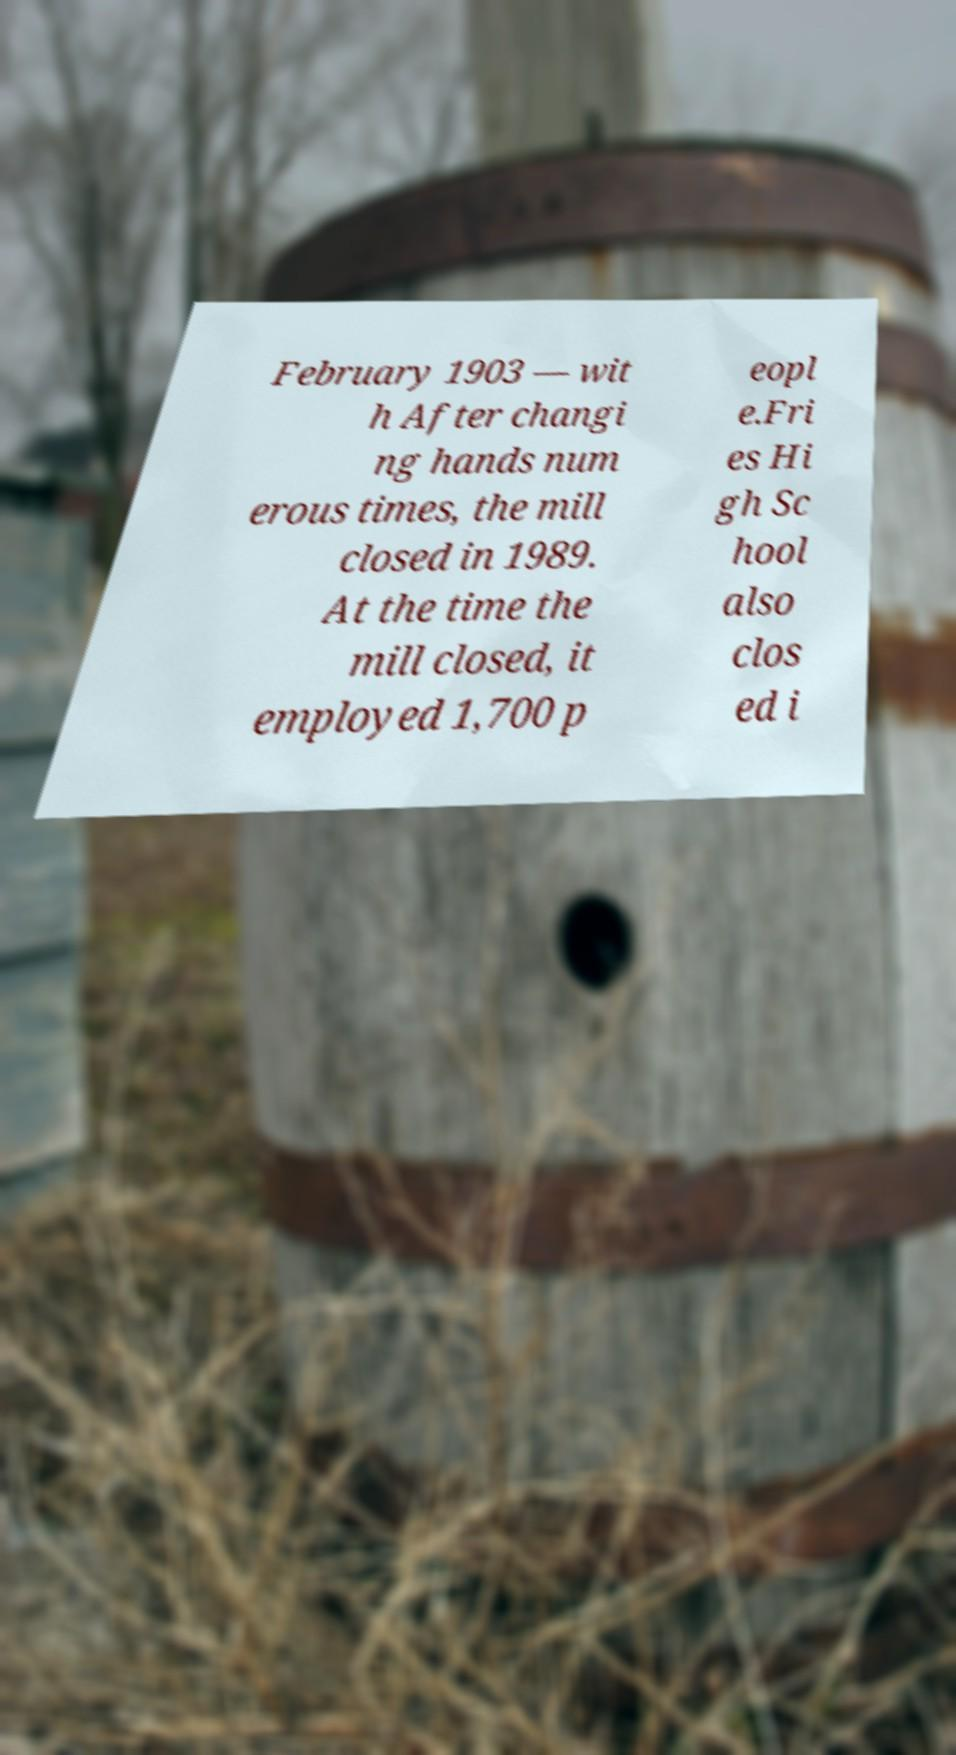Could you assist in decoding the text presented in this image and type it out clearly? February 1903 — wit h After changi ng hands num erous times, the mill closed in 1989. At the time the mill closed, it employed 1,700 p eopl e.Fri es Hi gh Sc hool also clos ed i 